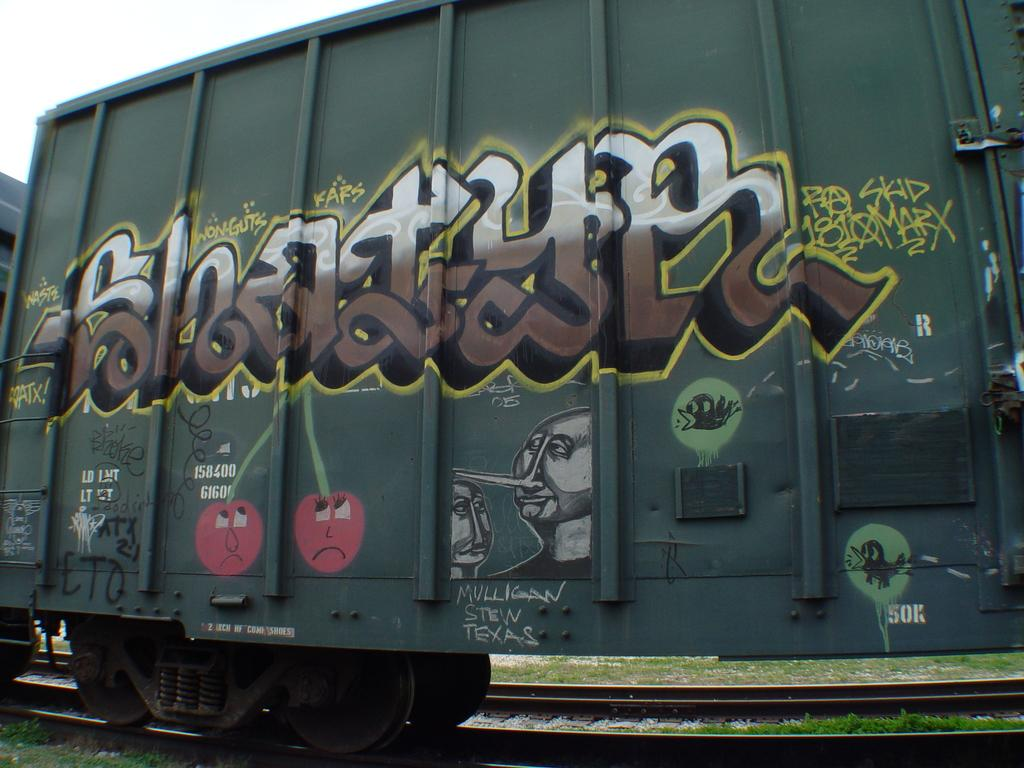What is the main subject of the image? The main subject of the image is a train. Where is the train located in the image? The train is on a track. What can be seen on the train? There is a painting on the train, and something is written on it. What can be seen in the background of the image? The sky is visible in the background of the image. How many bananas are hanging from the airplane in the image? There is no airplane or bananas present in the image. What number is written on the train in the image? The provided facts do not mention any specific numbers written on the train, so we cannot determine that information from the image. 